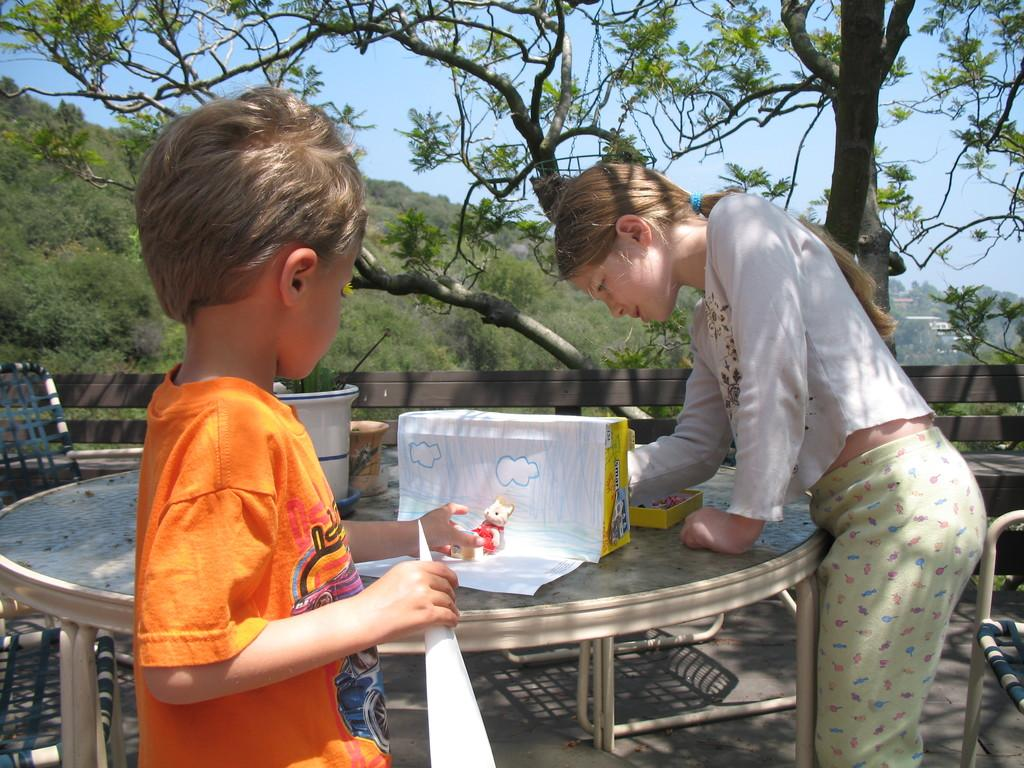Who are the people in the image? There is a boy and a girl in the image. What are the boy and girl doing in the image? They are standing near a table and working with papers. What can be seen in the background of the image? There are trees and hills visible in the background of the image. What type of snow can be seen on the ground in the image? There is no snow present in the image; it features trees and hills in the background. What is the governor doing in the image? There is no governor present in the image; it features a boy and a girl working with papers near a table. 